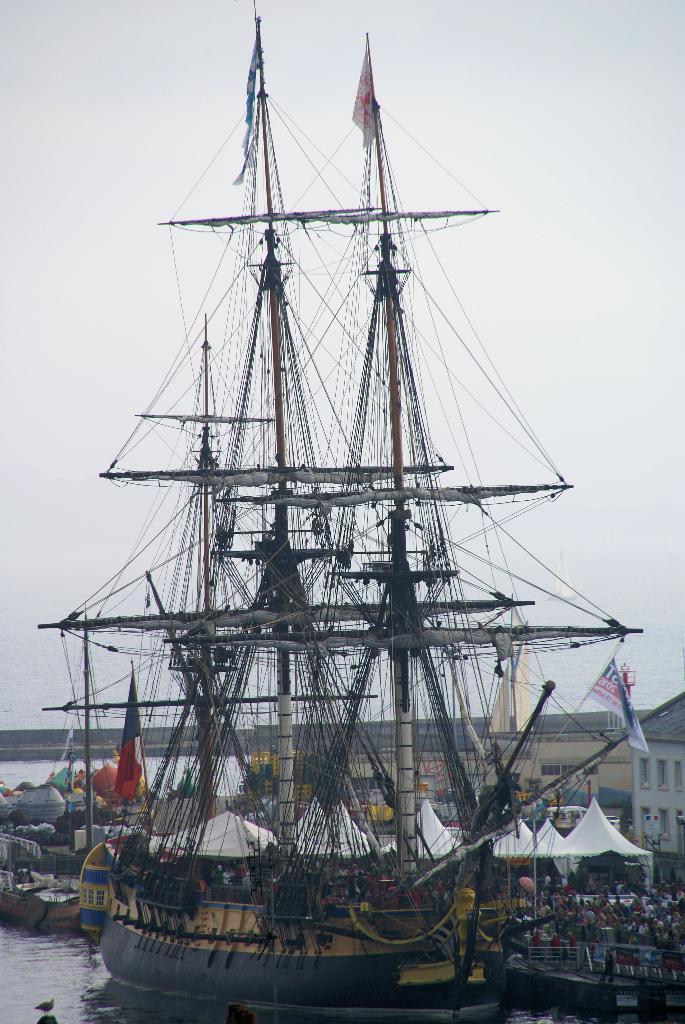In one or two sentences, can you explain what this image depicts? In this image, we can see a ship floating on the water. There are tents and buildings in the middle of the image. There is a sky at the top of the image. 